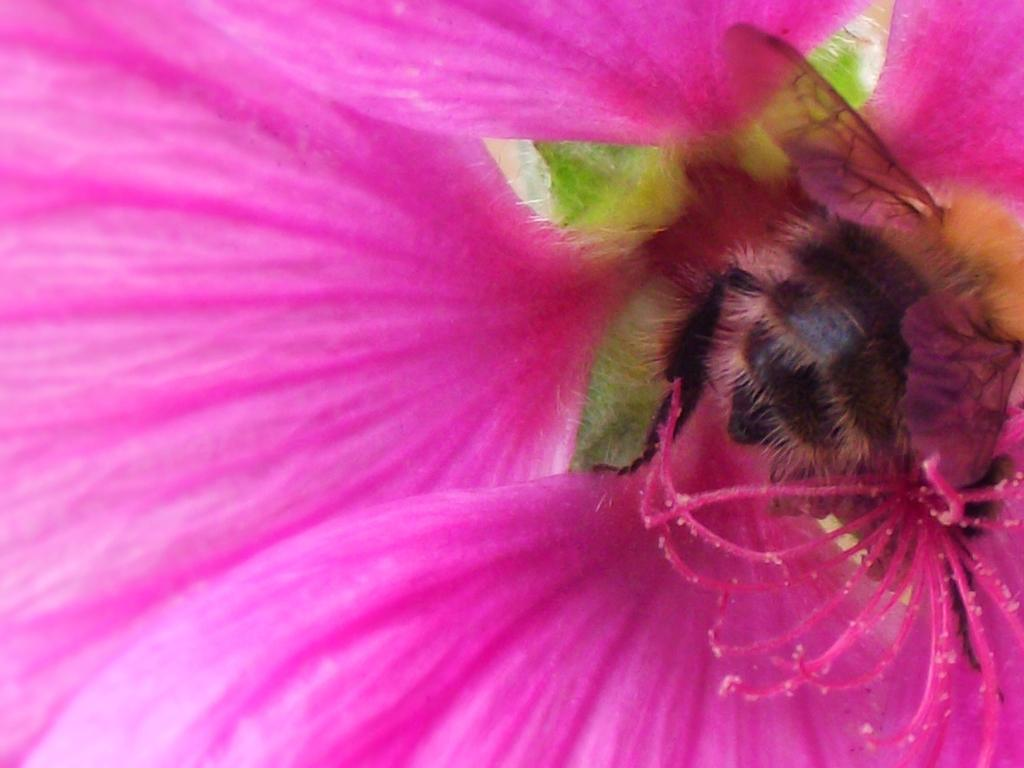What type of insect is present in the image? There is a honey bee in the image. Where is the honey bee located in the image? The honey bee is on a flower. What type of skate is being used by the honey bee in the image? There is no skate present in the image; the honey bee is on a flower. 